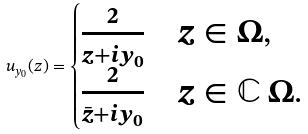<formula> <loc_0><loc_0><loc_500><loc_500>u _ { y _ { 0 } } ( z ) = \begin{cases} \frac { 2 } { z + i y _ { 0 } } & z \in \Omega , \\ \frac { 2 } { \bar { z } + i y _ { 0 } } & z \in \mathbb { C } \ \Omega . \end{cases}</formula> 